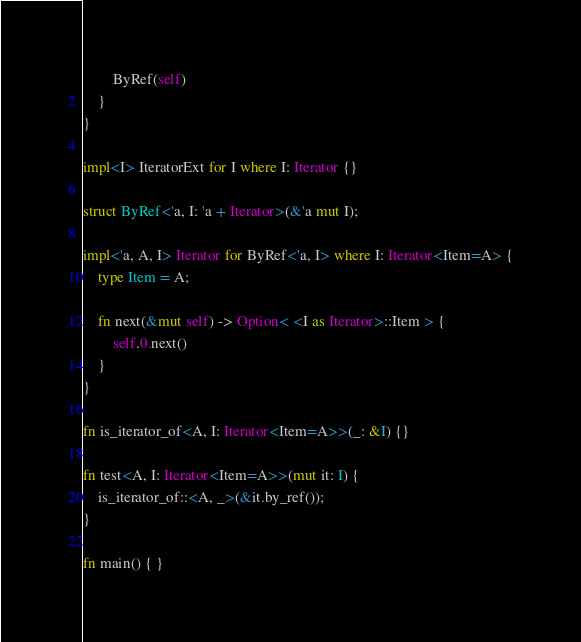Convert code to text. <code><loc_0><loc_0><loc_500><loc_500><_Rust_>        ByRef(self)
    }
}

impl<I> IteratorExt for I where I: Iterator {}

struct ByRef<'a, I: 'a + Iterator>(&'a mut I);

impl<'a, A, I> Iterator for ByRef<'a, I> where I: Iterator<Item=A> {
    type Item = A;

    fn next(&mut self) -> Option< <I as Iterator>::Item > {
        self.0.next()
    }
}

fn is_iterator_of<A, I: Iterator<Item=A>>(_: &I) {}

fn test<A, I: Iterator<Item=A>>(mut it: I) {
    is_iterator_of::<A, _>(&it.by_ref());
}

fn main() { }
</code> 